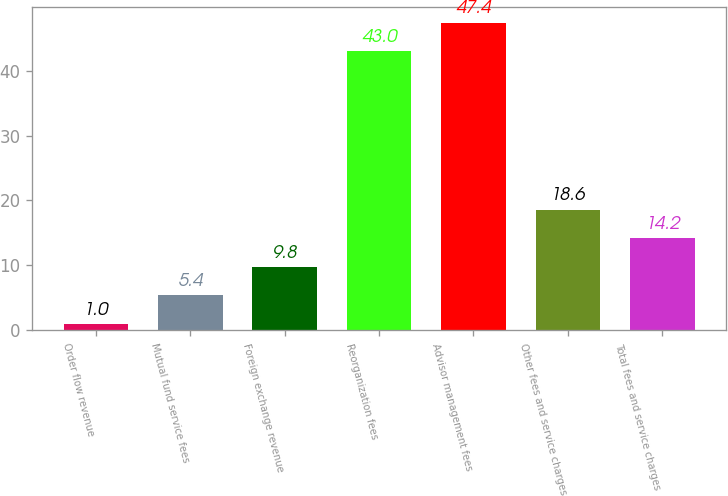Convert chart to OTSL. <chart><loc_0><loc_0><loc_500><loc_500><bar_chart><fcel>Order flow revenue<fcel>Mutual fund service fees<fcel>Foreign exchange revenue<fcel>Reorganization fees<fcel>Advisor management fees<fcel>Other fees and service charges<fcel>Total fees and service charges<nl><fcel>1<fcel>5.4<fcel>9.8<fcel>43<fcel>47.4<fcel>18.6<fcel>14.2<nl></chart> 